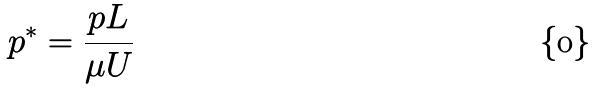<formula> <loc_0><loc_0><loc_500><loc_500>p ^ { * } = \frac { p L } { \mu U }</formula> 